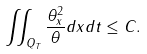Convert formula to latex. <formula><loc_0><loc_0><loc_500><loc_500>\iint _ { Q _ { T } } \frac { \theta _ { x } ^ { 2 } } { \theta } d x d t \leq C .</formula> 